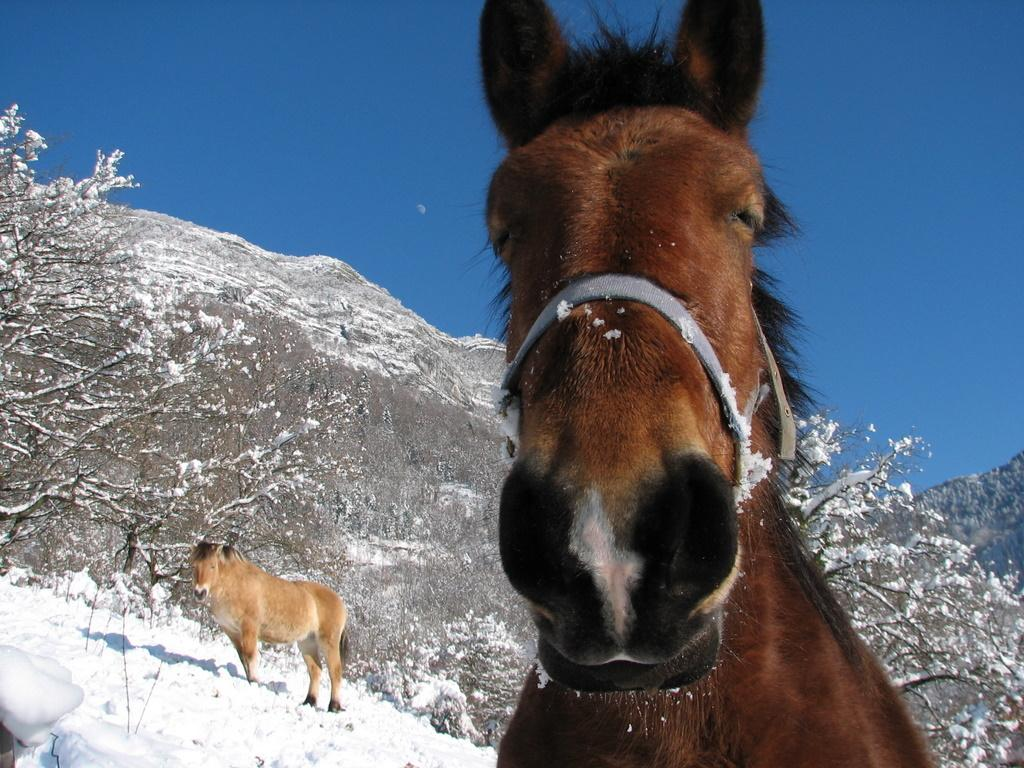How many horses are in the image? There are two horses in the image. What is the ground made of in the image? The horses are standing on snow in the image. What other features in the image are covered with snow? Hills and trees are covered with snow in the image. What can be seen in the background of the image? The sky is visible in the background of the image. What type of gun is being used by the horses in the image? There are no guns present in the image; it features two horses standing on snow with snow-covered hills and trees in the background. What kind of vessel is being transported by the horses in the image? There is no vessel being transported by the horses in the image; they are simply standing on snow. 